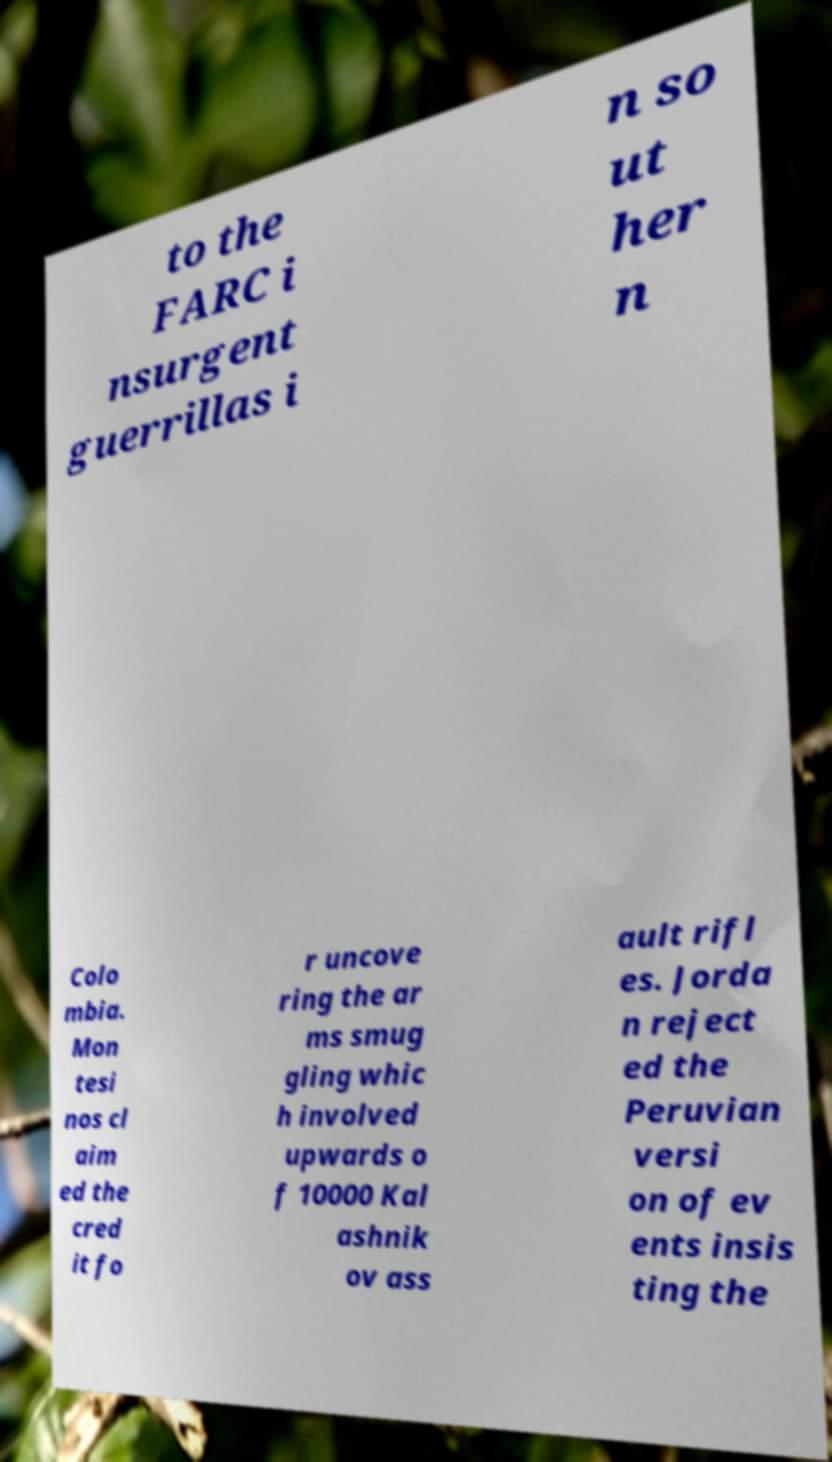There's text embedded in this image that I need extracted. Can you transcribe it verbatim? to the FARC i nsurgent guerrillas i n so ut her n Colo mbia. Mon tesi nos cl aim ed the cred it fo r uncove ring the ar ms smug gling whic h involved upwards o f 10000 Kal ashnik ov ass ault rifl es. Jorda n reject ed the Peruvian versi on of ev ents insis ting the 